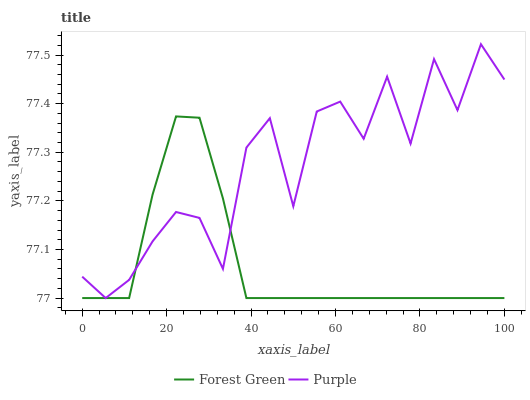Does Forest Green have the minimum area under the curve?
Answer yes or no. Yes. Does Purple have the maximum area under the curve?
Answer yes or no. Yes. Does Forest Green have the maximum area under the curve?
Answer yes or no. No. Is Forest Green the smoothest?
Answer yes or no. Yes. Is Purple the roughest?
Answer yes or no. Yes. Is Forest Green the roughest?
Answer yes or no. No. Does Purple have the lowest value?
Answer yes or no. Yes. Does Purple have the highest value?
Answer yes or no. Yes. Does Forest Green have the highest value?
Answer yes or no. No. Does Forest Green intersect Purple?
Answer yes or no. Yes. Is Forest Green less than Purple?
Answer yes or no. No. Is Forest Green greater than Purple?
Answer yes or no. No. 